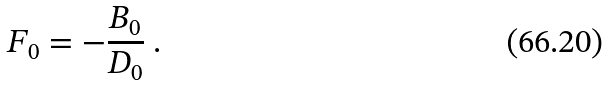Convert formula to latex. <formula><loc_0><loc_0><loc_500><loc_500>F _ { 0 } = - \frac { B _ { 0 } } { D _ { 0 } } \ .</formula> 